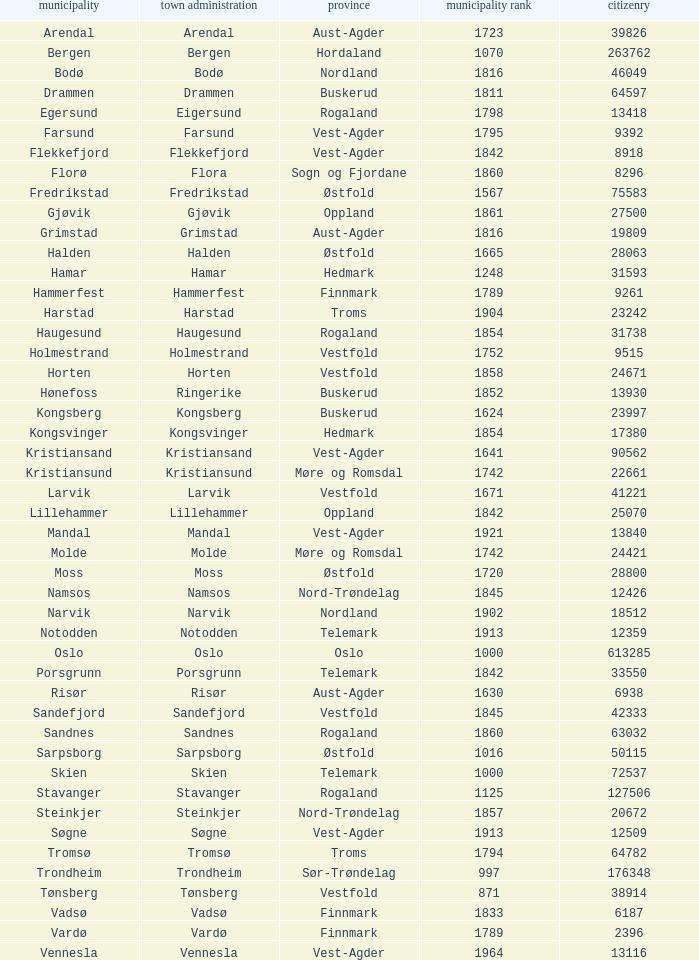What are the cities/towns located in the municipality of Horten? Horten. 